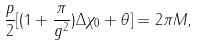<formula> <loc_0><loc_0><loc_500><loc_500>\frac { p } { 2 } [ ( 1 + \frac { \pi } { g ^ { 2 } } ) \Delta \chi _ { 0 } + \theta ] = 2 \pi M ,</formula> 